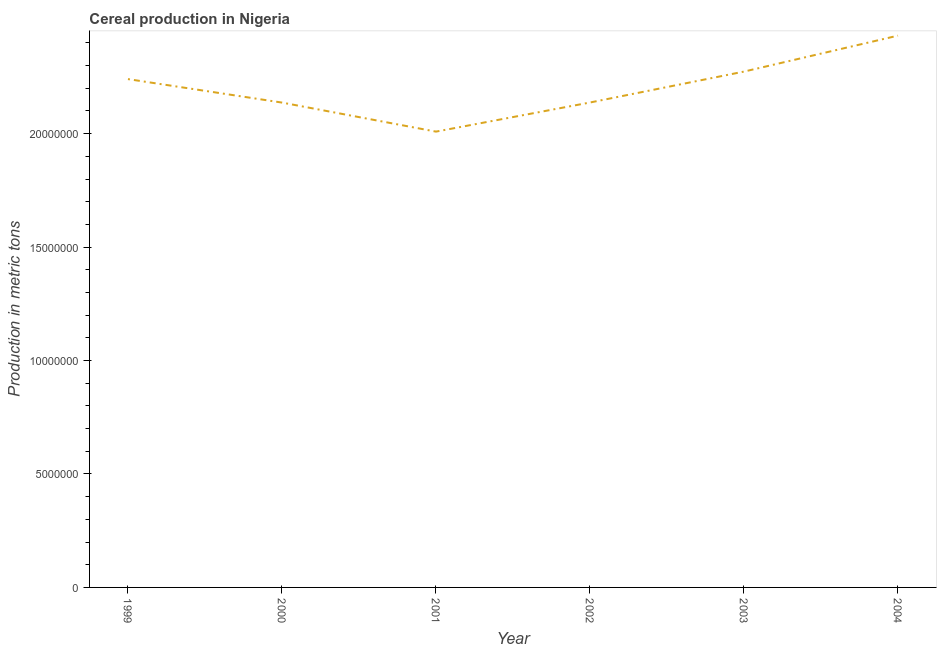What is the cereal production in 1999?
Your response must be concise. 2.24e+07. Across all years, what is the maximum cereal production?
Offer a terse response. 2.43e+07. Across all years, what is the minimum cereal production?
Give a very brief answer. 2.01e+07. In which year was the cereal production maximum?
Make the answer very short. 2004. What is the sum of the cereal production?
Provide a short and direct response. 1.32e+08. What is the difference between the cereal production in 2000 and 2004?
Offer a terse response. -2.95e+06. What is the average cereal production per year?
Your response must be concise. 2.20e+07. What is the median cereal production?
Offer a very short reply. 2.19e+07. In how many years, is the cereal production greater than 15000000 metric tons?
Make the answer very short. 6. Do a majority of the years between 1999 and 2002 (inclusive) have cereal production greater than 5000000 metric tons?
Provide a short and direct response. Yes. What is the ratio of the cereal production in 2000 to that in 2001?
Offer a terse response. 1.06. Is the cereal production in 2000 less than that in 2003?
Provide a succinct answer. Yes. What is the difference between the highest and the second highest cereal production?
Keep it short and to the point. 1.58e+06. What is the difference between the highest and the lowest cereal production?
Offer a terse response. 4.23e+06. In how many years, is the cereal production greater than the average cereal production taken over all years?
Make the answer very short. 3. How many lines are there?
Offer a terse response. 1. How many years are there in the graph?
Provide a short and direct response. 6. Are the values on the major ticks of Y-axis written in scientific E-notation?
Your response must be concise. No. What is the title of the graph?
Provide a succinct answer. Cereal production in Nigeria. What is the label or title of the Y-axis?
Provide a succinct answer. Production in metric tons. What is the Production in metric tons in 1999?
Offer a terse response. 2.24e+07. What is the Production in metric tons in 2000?
Provide a succinct answer. 2.14e+07. What is the Production in metric tons of 2001?
Make the answer very short. 2.01e+07. What is the Production in metric tons in 2002?
Your answer should be very brief. 2.14e+07. What is the Production in metric tons of 2003?
Your response must be concise. 2.27e+07. What is the Production in metric tons of 2004?
Provide a short and direct response. 2.43e+07. What is the difference between the Production in metric tons in 1999 and 2000?
Ensure brevity in your answer.  1.04e+06. What is the difference between the Production in metric tons in 1999 and 2001?
Offer a terse response. 2.32e+06. What is the difference between the Production in metric tons in 1999 and 2002?
Your answer should be compact. 1.03e+06. What is the difference between the Production in metric tons in 1999 and 2003?
Your response must be concise. -3.31e+05. What is the difference between the Production in metric tons in 1999 and 2004?
Provide a short and direct response. -1.92e+06. What is the difference between the Production in metric tons in 2000 and 2001?
Offer a terse response. 1.28e+06. What is the difference between the Production in metric tons in 2000 and 2002?
Make the answer very short. -3000. What is the difference between the Production in metric tons in 2000 and 2003?
Your answer should be very brief. -1.37e+06. What is the difference between the Production in metric tons in 2000 and 2004?
Offer a very short reply. -2.95e+06. What is the difference between the Production in metric tons in 2001 and 2002?
Make the answer very short. -1.28e+06. What is the difference between the Production in metric tons in 2001 and 2003?
Provide a short and direct response. -2.65e+06. What is the difference between the Production in metric tons in 2001 and 2004?
Give a very brief answer. -4.23e+06. What is the difference between the Production in metric tons in 2002 and 2003?
Provide a succinct answer. -1.36e+06. What is the difference between the Production in metric tons in 2002 and 2004?
Offer a terse response. -2.95e+06. What is the difference between the Production in metric tons in 2003 and 2004?
Keep it short and to the point. -1.58e+06. What is the ratio of the Production in metric tons in 1999 to that in 2000?
Your response must be concise. 1.05. What is the ratio of the Production in metric tons in 1999 to that in 2001?
Give a very brief answer. 1.11. What is the ratio of the Production in metric tons in 1999 to that in 2002?
Keep it short and to the point. 1.05. What is the ratio of the Production in metric tons in 1999 to that in 2004?
Your answer should be very brief. 0.92. What is the ratio of the Production in metric tons in 2000 to that in 2001?
Keep it short and to the point. 1.06. What is the ratio of the Production in metric tons in 2000 to that in 2002?
Offer a terse response. 1. What is the ratio of the Production in metric tons in 2000 to that in 2004?
Keep it short and to the point. 0.88. What is the ratio of the Production in metric tons in 2001 to that in 2002?
Ensure brevity in your answer.  0.94. What is the ratio of the Production in metric tons in 2001 to that in 2003?
Your response must be concise. 0.88. What is the ratio of the Production in metric tons in 2001 to that in 2004?
Ensure brevity in your answer.  0.83. What is the ratio of the Production in metric tons in 2002 to that in 2004?
Keep it short and to the point. 0.88. What is the ratio of the Production in metric tons in 2003 to that in 2004?
Give a very brief answer. 0.94. 